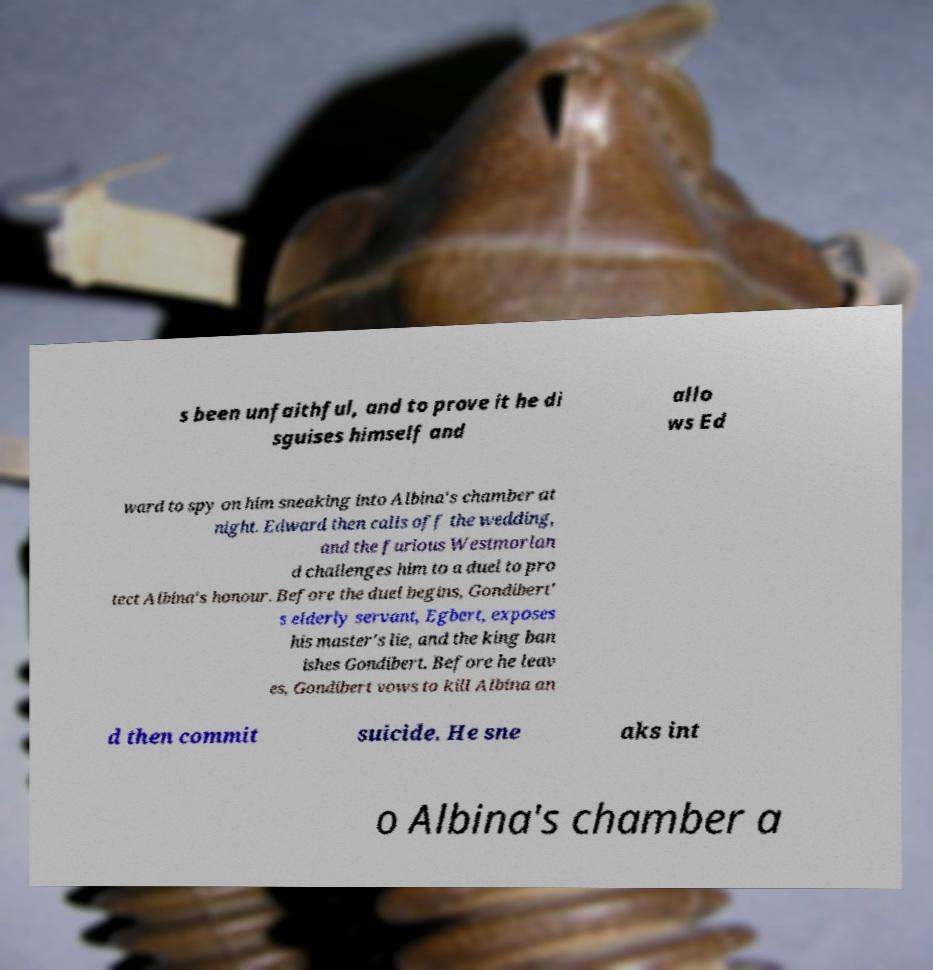For documentation purposes, I need the text within this image transcribed. Could you provide that? s been unfaithful, and to prove it he di sguises himself and allo ws Ed ward to spy on him sneaking into Albina's chamber at night. Edward then calls off the wedding, and the furious Westmorlan d challenges him to a duel to pro tect Albina's honour. Before the duel begins, Gondibert' s elderly servant, Egbert, exposes his master's lie, and the king ban ishes Gondibert. Before he leav es, Gondibert vows to kill Albina an d then commit suicide. He sne aks int o Albina's chamber a 